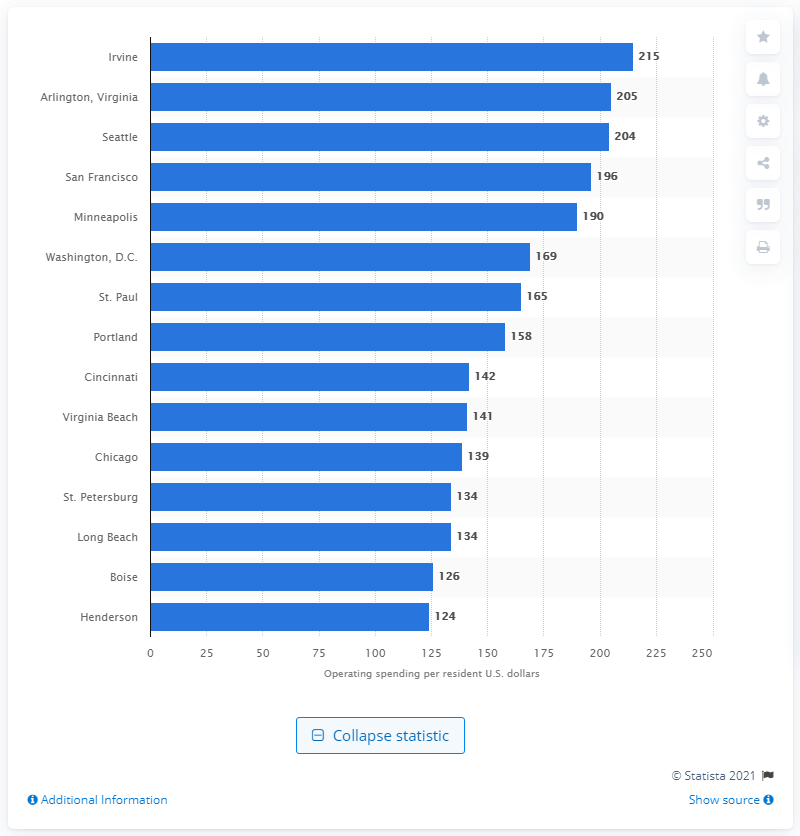Point out several critical features in this image. In 2016, Irvine's operating spending on parks and recreation was $215 per resident. 